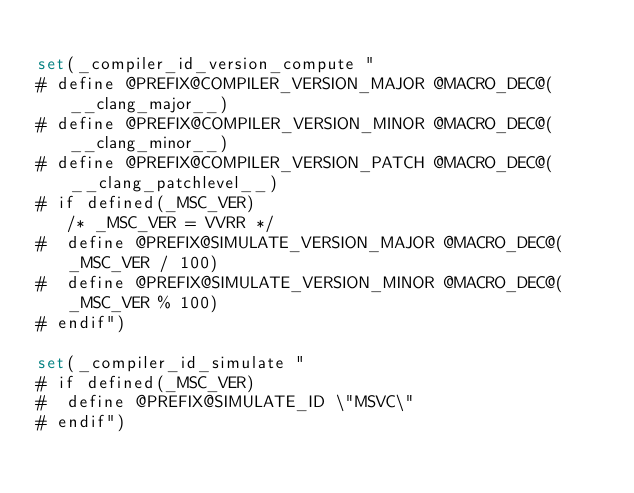Convert code to text. <code><loc_0><loc_0><loc_500><loc_500><_CMake_>
set(_compiler_id_version_compute "
# define @PREFIX@COMPILER_VERSION_MAJOR @MACRO_DEC@(__clang_major__)
# define @PREFIX@COMPILER_VERSION_MINOR @MACRO_DEC@(__clang_minor__)
# define @PREFIX@COMPILER_VERSION_PATCH @MACRO_DEC@(__clang_patchlevel__)
# if defined(_MSC_VER)
   /* _MSC_VER = VVRR */
#  define @PREFIX@SIMULATE_VERSION_MAJOR @MACRO_DEC@(_MSC_VER / 100)
#  define @PREFIX@SIMULATE_VERSION_MINOR @MACRO_DEC@(_MSC_VER % 100)
# endif")

set(_compiler_id_simulate "
# if defined(_MSC_VER)
#  define @PREFIX@SIMULATE_ID \"MSVC\"
# endif")
</code> 